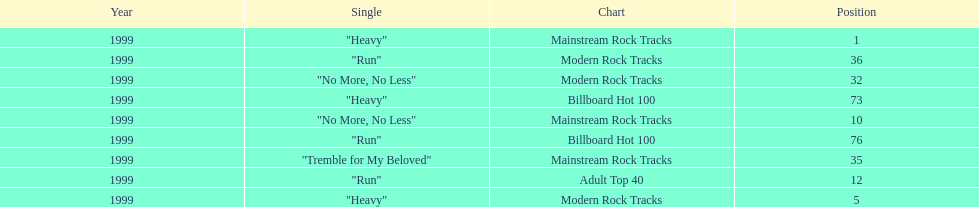How many singles from "dosage" appeared on the modern rock tracks charts? 3. 